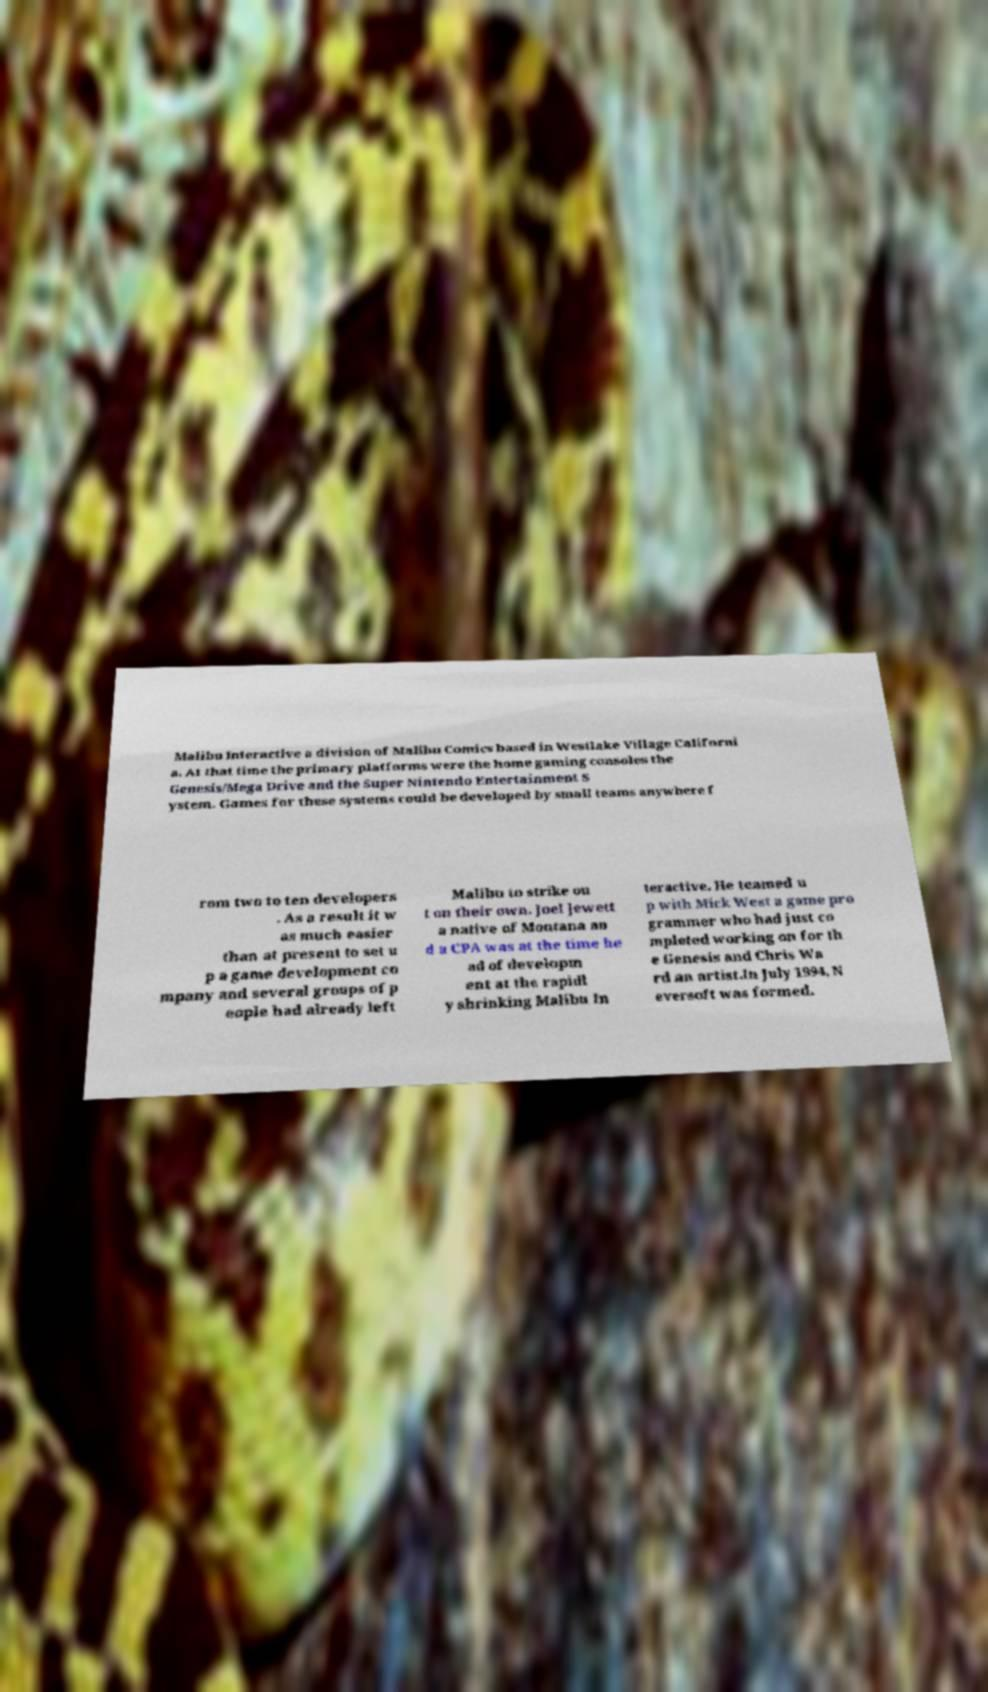Please identify and transcribe the text found in this image. Malibu Interactive a division of Malibu Comics based in Westlake Village Californi a. At that time the primary platforms were the home gaming consoles the Genesis/Mega Drive and the Super Nintendo Entertainment S ystem. Games for these systems could be developed by small teams anywhere f rom two to ten developers . As a result it w as much easier than at present to set u p a game development co mpany and several groups of p eople had already left Malibu to strike ou t on their own. Joel Jewett a native of Montana an d a CPA was at the time he ad of developm ent at the rapidl y shrinking Malibu In teractive. He teamed u p with Mick West a game pro grammer who had just co mpleted working on for th e Genesis and Chris Wa rd an artist.In July 1994, N eversoft was formed. 